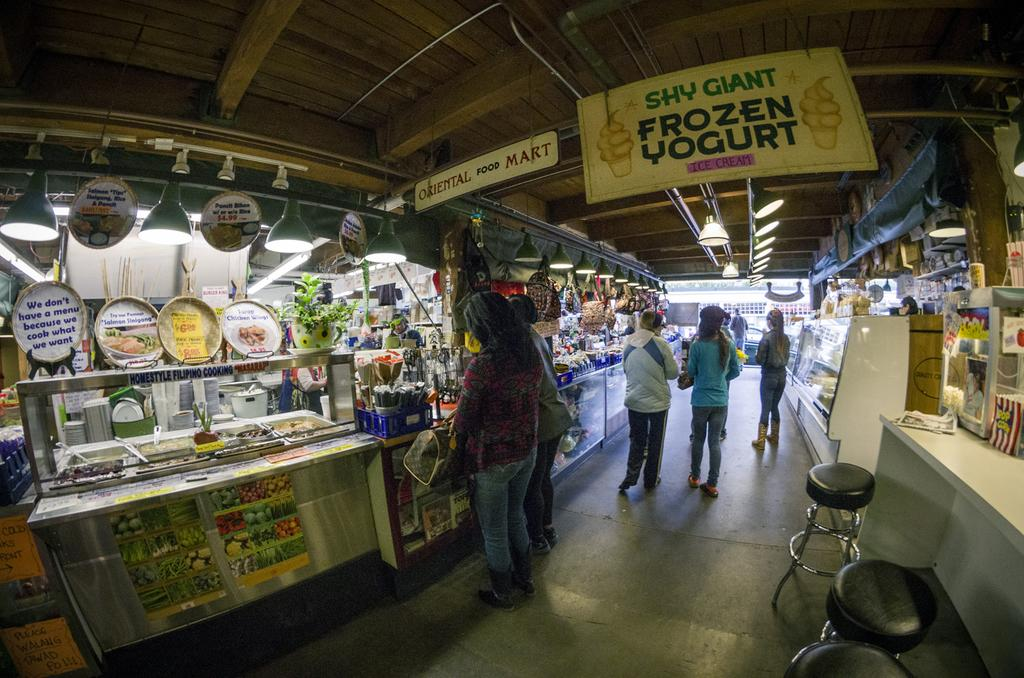<image>
Give a short and clear explanation of the subsequent image. A food court with a banner advertising Shy Giant frozen yogurt. 